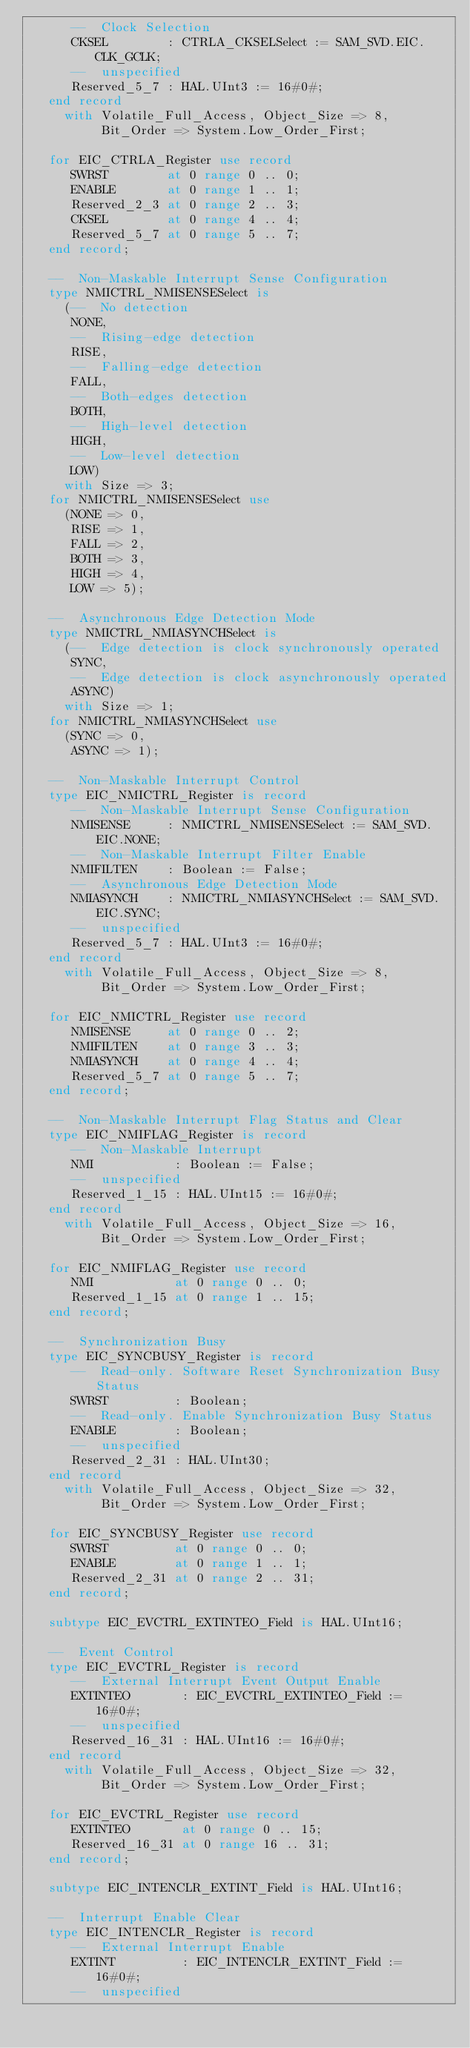Convert code to text. <code><loc_0><loc_0><loc_500><loc_500><_Ada_>      --  Clock Selection
      CKSEL        : CTRLA_CKSELSelect := SAM_SVD.EIC.CLK_GCLK;
      --  unspecified
      Reserved_5_7 : HAL.UInt3 := 16#0#;
   end record
     with Volatile_Full_Access, Object_Size => 8,
          Bit_Order => System.Low_Order_First;

   for EIC_CTRLA_Register use record
      SWRST        at 0 range 0 .. 0;
      ENABLE       at 0 range 1 .. 1;
      Reserved_2_3 at 0 range 2 .. 3;
      CKSEL        at 0 range 4 .. 4;
      Reserved_5_7 at 0 range 5 .. 7;
   end record;

   --  Non-Maskable Interrupt Sense Configuration
   type NMICTRL_NMISENSESelect is
     (--  No detection
      NONE,
      --  Rising-edge detection
      RISE,
      --  Falling-edge detection
      FALL,
      --  Both-edges detection
      BOTH,
      --  High-level detection
      HIGH,
      --  Low-level detection
      LOW)
     with Size => 3;
   for NMICTRL_NMISENSESelect use
     (NONE => 0,
      RISE => 1,
      FALL => 2,
      BOTH => 3,
      HIGH => 4,
      LOW => 5);

   --  Asynchronous Edge Detection Mode
   type NMICTRL_NMIASYNCHSelect is
     (--  Edge detection is clock synchronously operated
      SYNC,
      --  Edge detection is clock asynchronously operated
      ASYNC)
     with Size => 1;
   for NMICTRL_NMIASYNCHSelect use
     (SYNC => 0,
      ASYNC => 1);

   --  Non-Maskable Interrupt Control
   type EIC_NMICTRL_Register is record
      --  Non-Maskable Interrupt Sense Configuration
      NMISENSE     : NMICTRL_NMISENSESelect := SAM_SVD.EIC.NONE;
      --  Non-Maskable Interrupt Filter Enable
      NMIFILTEN    : Boolean := False;
      --  Asynchronous Edge Detection Mode
      NMIASYNCH    : NMICTRL_NMIASYNCHSelect := SAM_SVD.EIC.SYNC;
      --  unspecified
      Reserved_5_7 : HAL.UInt3 := 16#0#;
   end record
     with Volatile_Full_Access, Object_Size => 8,
          Bit_Order => System.Low_Order_First;

   for EIC_NMICTRL_Register use record
      NMISENSE     at 0 range 0 .. 2;
      NMIFILTEN    at 0 range 3 .. 3;
      NMIASYNCH    at 0 range 4 .. 4;
      Reserved_5_7 at 0 range 5 .. 7;
   end record;

   --  Non-Maskable Interrupt Flag Status and Clear
   type EIC_NMIFLAG_Register is record
      --  Non-Maskable Interrupt
      NMI           : Boolean := False;
      --  unspecified
      Reserved_1_15 : HAL.UInt15 := 16#0#;
   end record
     with Volatile_Full_Access, Object_Size => 16,
          Bit_Order => System.Low_Order_First;

   for EIC_NMIFLAG_Register use record
      NMI           at 0 range 0 .. 0;
      Reserved_1_15 at 0 range 1 .. 15;
   end record;

   --  Synchronization Busy
   type EIC_SYNCBUSY_Register is record
      --  Read-only. Software Reset Synchronization Busy Status
      SWRST         : Boolean;
      --  Read-only. Enable Synchronization Busy Status
      ENABLE        : Boolean;
      --  unspecified
      Reserved_2_31 : HAL.UInt30;
   end record
     with Volatile_Full_Access, Object_Size => 32,
          Bit_Order => System.Low_Order_First;

   for EIC_SYNCBUSY_Register use record
      SWRST         at 0 range 0 .. 0;
      ENABLE        at 0 range 1 .. 1;
      Reserved_2_31 at 0 range 2 .. 31;
   end record;

   subtype EIC_EVCTRL_EXTINTEO_Field is HAL.UInt16;

   --  Event Control
   type EIC_EVCTRL_Register is record
      --  External Interrupt Event Output Enable
      EXTINTEO       : EIC_EVCTRL_EXTINTEO_Field := 16#0#;
      --  unspecified
      Reserved_16_31 : HAL.UInt16 := 16#0#;
   end record
     with Volatile_Full_Access, Object_Size => 32,
          Bit_Order => System.Low_Order_First;

   for EIC_EVCTRL_Register use record
      EXTINTEO       at 0 range 0 .. 15;
      Reserved_16_31 at 0 range 16 .. 31;
   end record;

   subtype EIC_INTENCLR_EXTINT_Field is HAL.UInt16;

   --  Interrupt Enable Clear
   type EIC_INTENCLR_Register is record
      --  External Interrupt Enable
      EXTINT         : EIC_INTENCLR_EXTINT_Field := 16#0#;
      --  unspecified</code> 